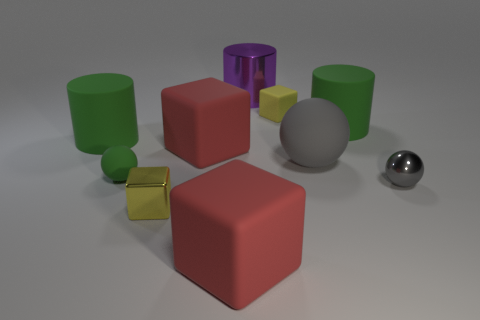Are there the same number of green things that are in front of the small green object and metallic cylinders that are on the left side of the yellow metal block?
Provide a succinct answer. Yes. What is the color of the tiny sphere that is on the left side of the big red thing that is in front of the red rubber cube that is behind the small gray object?
Provide a succinct answer. Green. Is there any other thing that is the same color as the big metallic cylinder?
Keep it short and to the point. No. What is the shape of the big matte thing that is the same color as the tiny shiny sphere?
Your answer should be very brief. Sphere. There is a ball left of the purple shiny object; what size is it?
Give a very brief answer. Small. There is another yellow object that is the same size as the yellow metal thing; what shape is it?
Offer a very short reply. Cube. Are the yellow object on the right side of the big purple cylinder and the gray ball that is on the right side of the gray rubber ball made of the same material?
Offer a very short reply. No. There is a small object that is behind the rubber cylinder on the left side of the big metal cylinder; what is it made of?
Make the answer very short. Rubber. There is a green object that is on the right side of the small yellow cube on the right side of the large thing that is in front of the metallic ball; what is its size?
Offer a terse response. Large. Is the size of the gray rubber object the same as the yellow metal cube?
Ensure brevity in your answer.  No. 